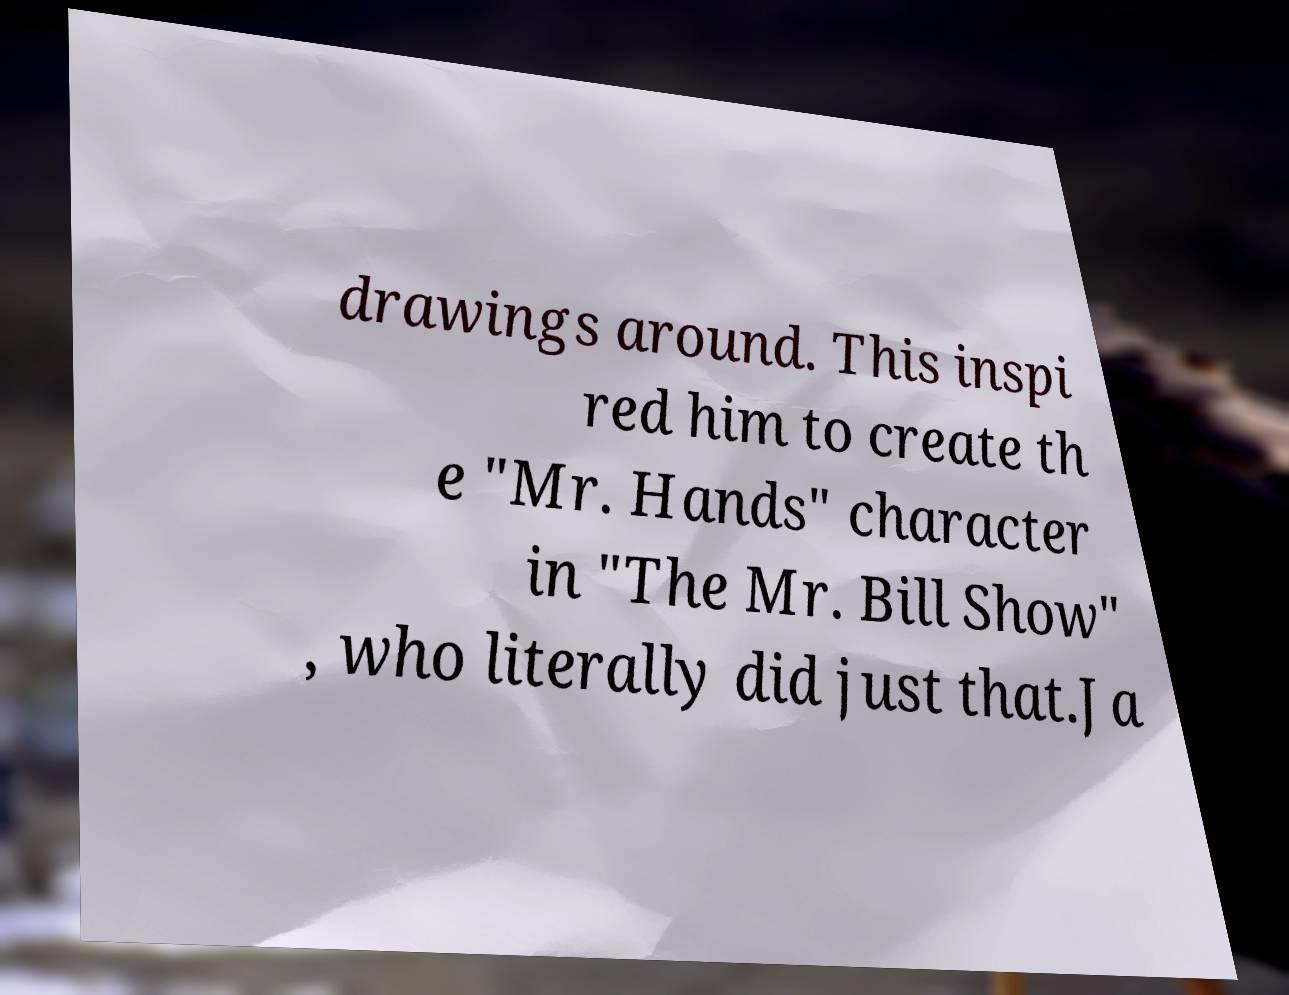Can you read and provide the text displayed in the image?This photo seems to have some interesting text. Can you extract and type it out for me? drawings around. This inspi red him to create th e "Mr. Hands" character in "The Mr. Bill Show" , who literally did just that.Ja 